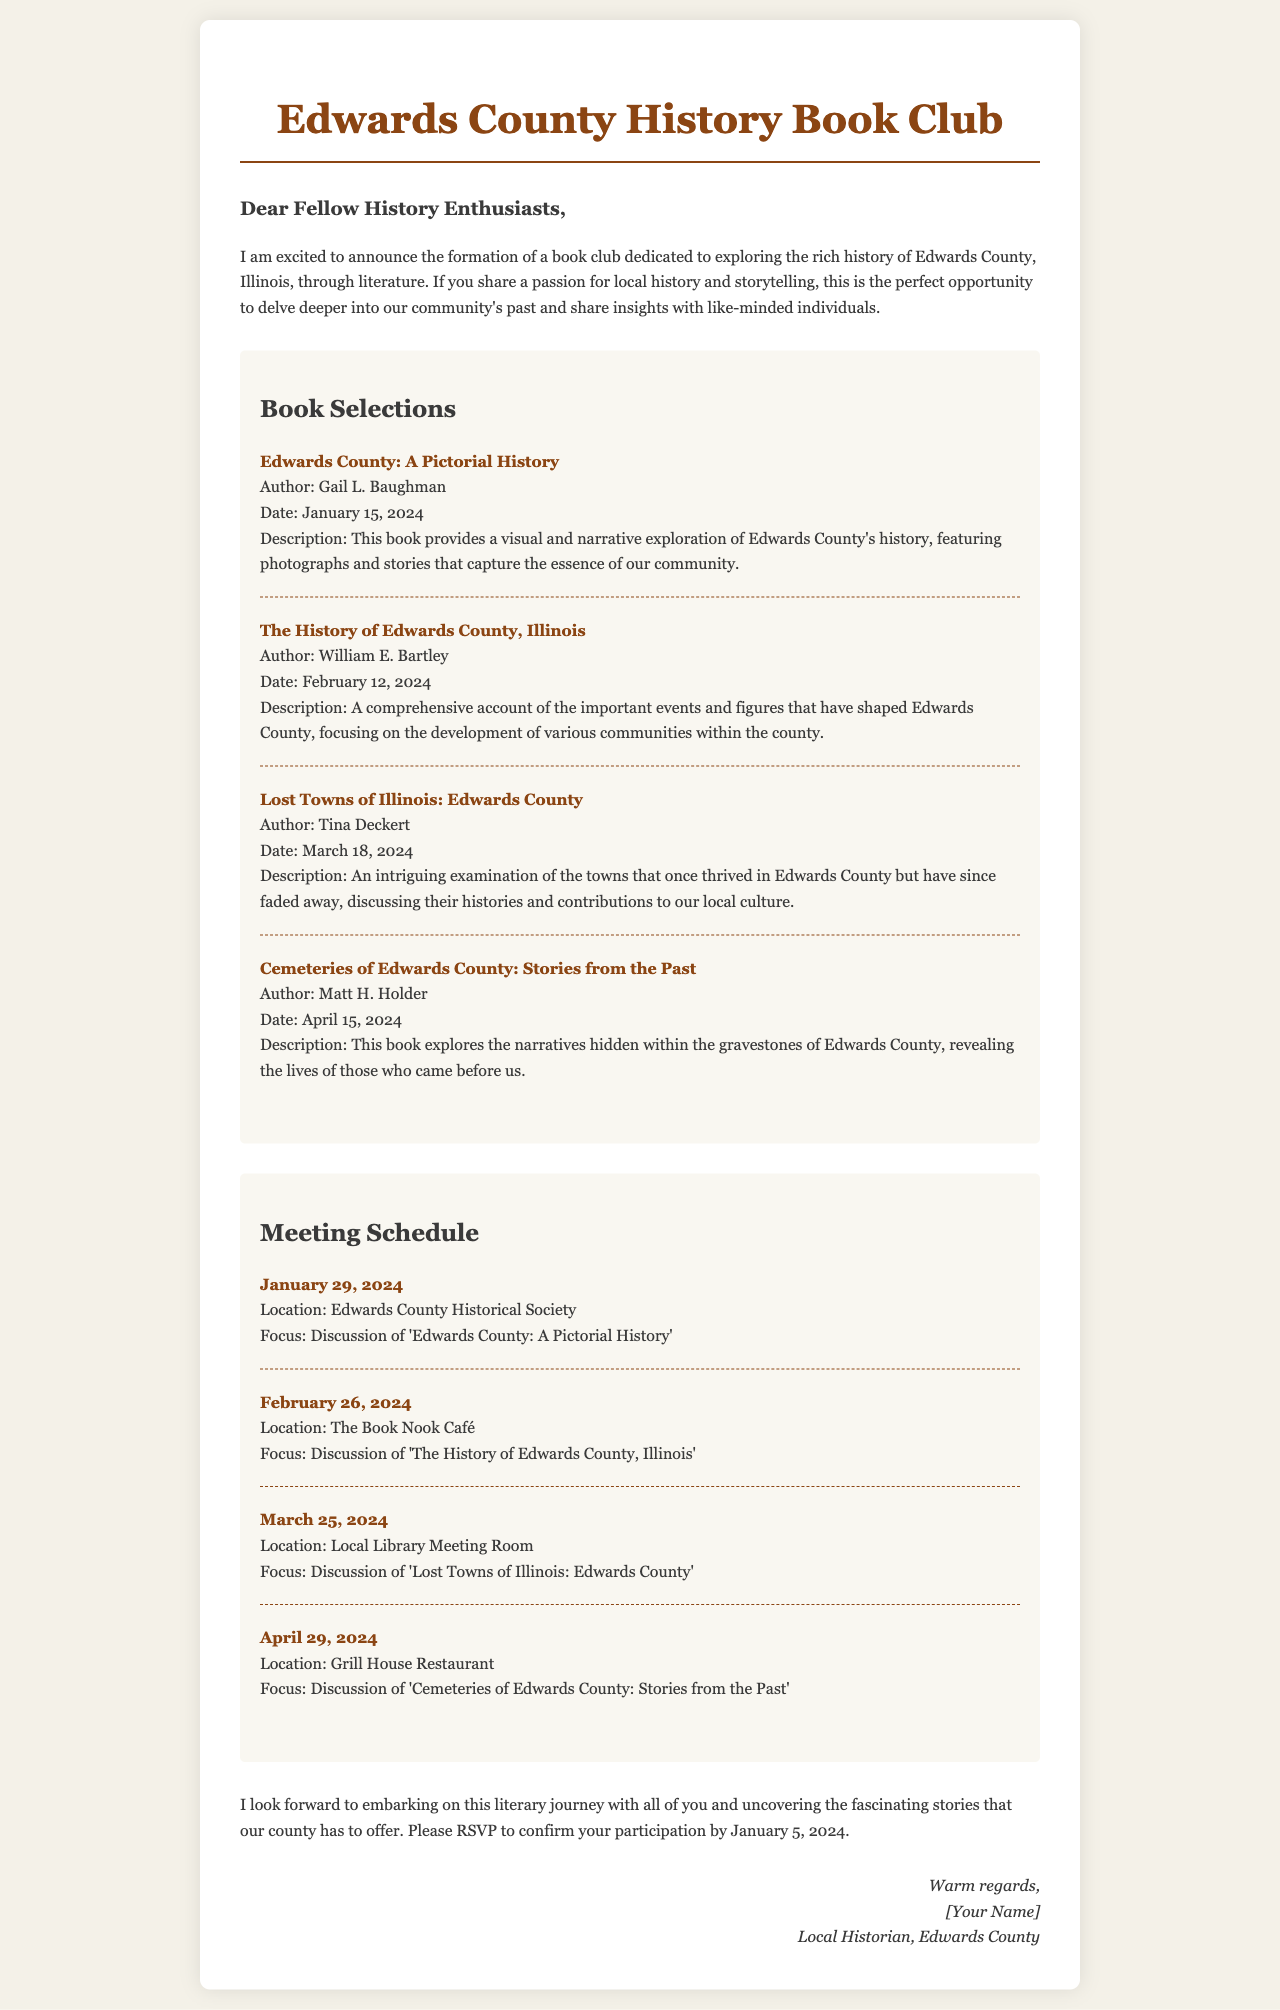What is the name of the book club? The name of the book club is mentioned in the title of the document.
Answer: Edwards County History Book Club Who is the author of "Cemeteries of Edwards County: Stories from the Past"? The author is directly listed under the book title in the document.
Answer: Matt H. Holder When is the meeting to discuss "Lost Towns of Illinois: Edwards County"? The date is provided in the meeting schedule section of the document.
Answer: March 25, 2024 Where will the first meeting be held? The location for the first meeting is specified in the meeting schedule.
Answer: Edwards County Historical Society How many books are listed in the book selections? The total number of books can be counted from the provided list in the document.
Answer: Four What is the focus of the meeting on April 29, 2024? The focus is stated next to the meeting date in the meeting list.
Answer: Discussion of 'Cemeteries of Edwards County: Stories from the Past' What is the RSVP deadline? The RSVP deadline is clearly mentioned in the closing section of the document.
Answer: January 5, 2024 Which café is mentioned as a meeting location? The meeting location is provided in the meeting schedule section.
Answer: The Book Nook Café What type of literature does the book club focus on? The genre is implied by the nature of the book selections listed in the document.
Answer: Local history literature 